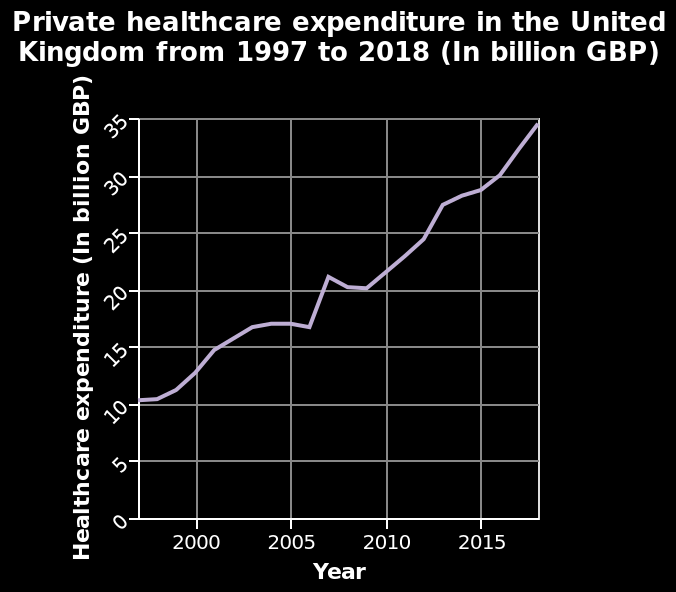<image>
Describe the following image in detail This is a line graph called Private healthcare expenditure in the United Kingdom from 1997 to 2018 (In billion GBP). The x-axis shows Year while the y-axis shows Healthcare expenditure (In billion GBP). please summary the statistics and relations of the chart Between 1997 and 2018, expenditure in healthcare in the UK has more than tripled. At some points (around 2004 and 2007) expenditure has dipped, however has increased quickly in the space of a year or two. How has healthcare expenditure in the UK changed between 1997 and 2018?  Healthcare expenditure in the UK has more than tripled between 1997 and 2018. 